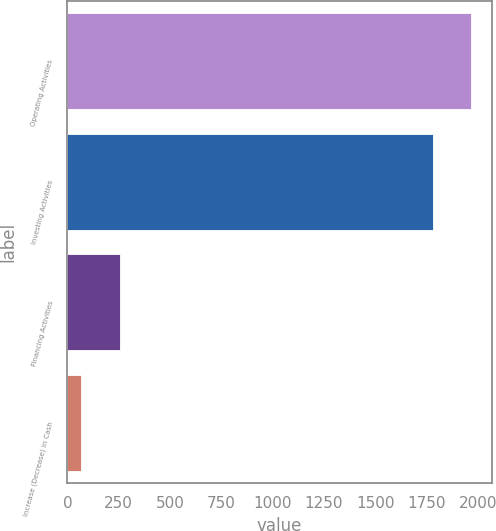<chart> <loc_0><loc_0><loc_500><loc_500><bar_chart><fcel>Operating Activities<fcel>Investing Activities<fcel>Financing Activities<fcel>Increase (Decrease) in Cash<nl><fcel>1966.9<fcel>1779<fcel>254.9<fcel>67<nl></chart> 